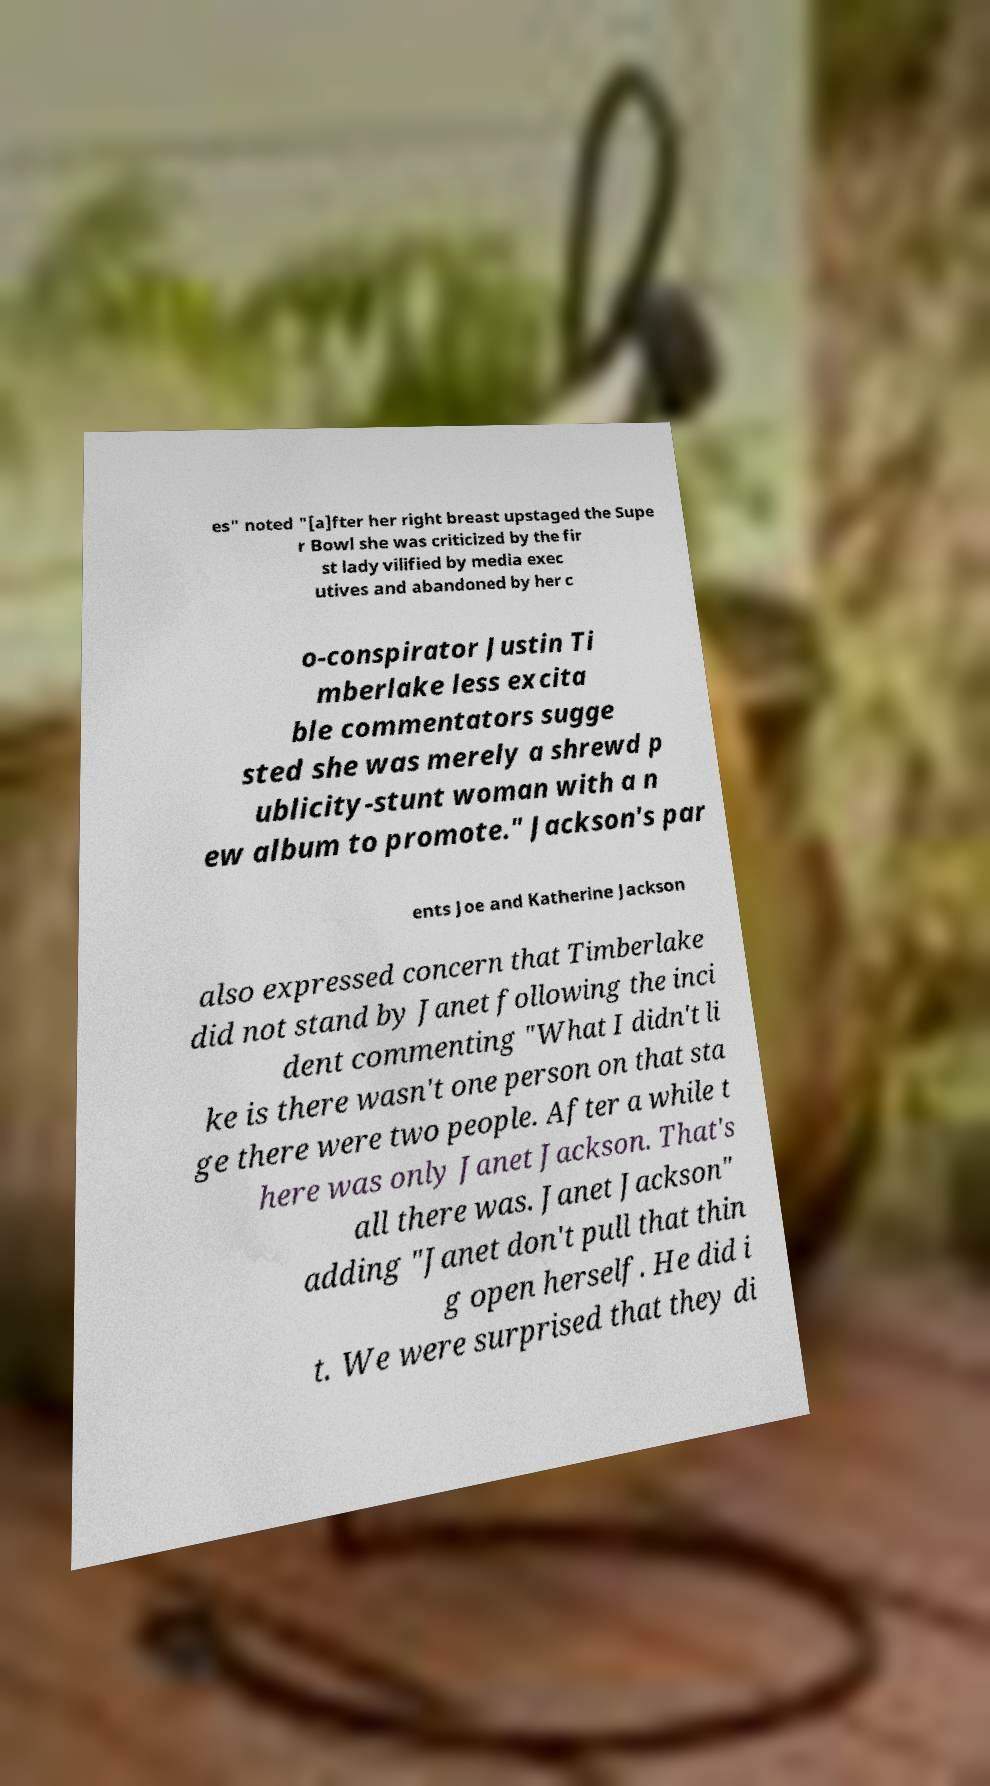I need the written content from this picture converted into text. Can you do that? es" noted "[a]fter her right breast upstaged the Supe r Bowl she was criticized by the fir st lady vilified by media exec utives and abandoned by her c o-conspirator Justin Ti mberlake less excita ble commentators sugge sted she was merely a shrewd p ublicity-stunt woman with a n ew album to promote." Jackson's par ents Joe and Katherine Jackson also expressed concern that Timberlake did not stand by Janet following the inci dent commenting "What I didn't li ke is there wasn't one person on that sta ge there were two people. After a while t here was only Janet Jackson. That's all there was. Janet Jackson" adding "Janet don't pull that thin g open herself. He did i t. We were surprised that they di 